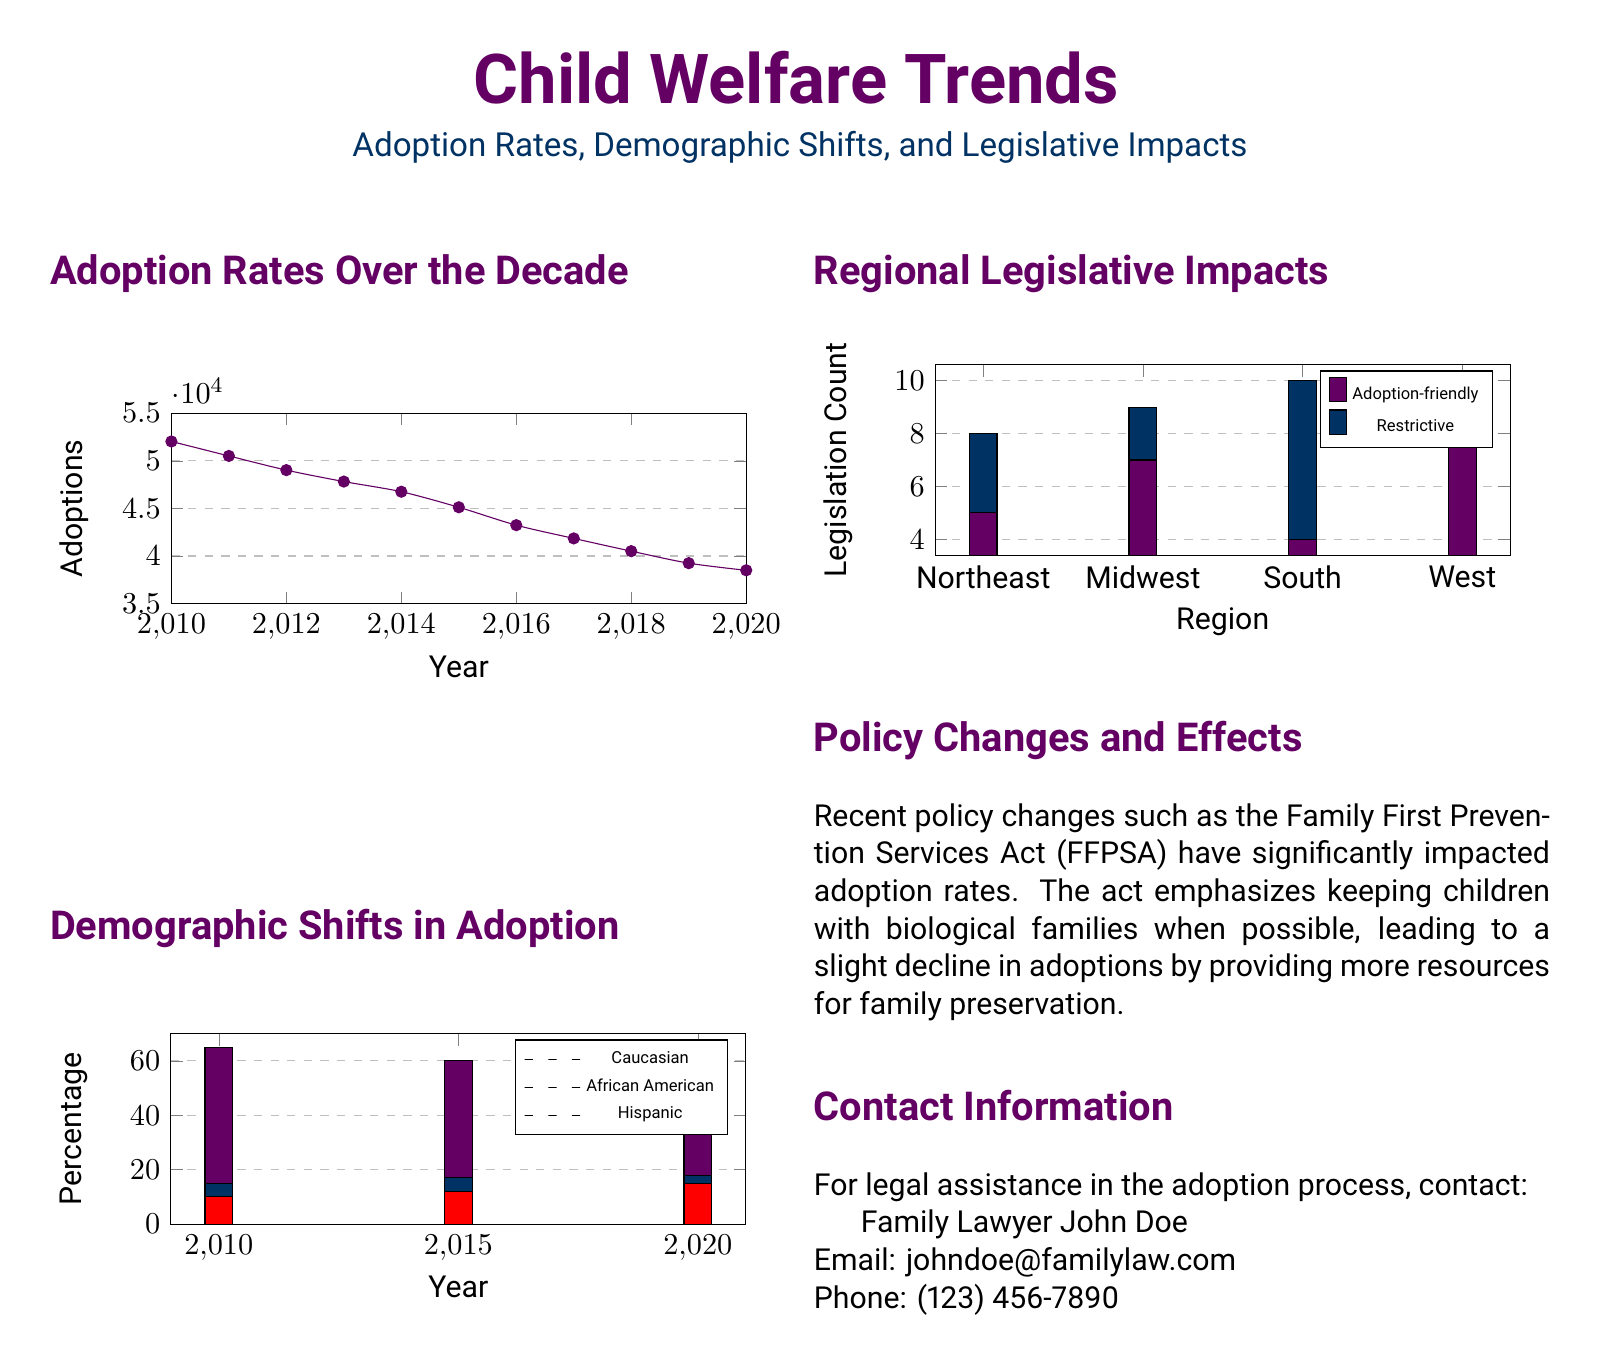What was the adoption rate in 2010? The adoption rate in 2010 is explicitly mentioned as 52034 adoptions.
Answer: 52034 What percentage of Caucasian adoptions was recorded in 2020? The percentage of Caucasian adoptions in 2020 is shown to be 55%.
Answer: 55% Which region had the highest count of adoption-friendly legislation? The region with the highest count of adoption-friendly legislation is West with a count of 8.
Answer: West How many African American adoptions were recorded in 2015? The number of African American adoptions in 2015 is represented as 17%.
Answer: 17% What legislative impact was most noted in the document? The document highlights the significant impact of the Family First Prevention Services Act (FFPSA) on adoption rates.
Answer: Family First Prevention Services Act What was the total number of adoptions in 2020? The total number of adoptions in 2020 is directly stated as 38500 adoptions.
Answer: 38500 What color represents Hispanic adoptions in the demographic shifts chart? The color red is used to represent Hispanic adoptions in the demographic shifts chart.
Answer: Red Which year saw the lowest adoption rate in the graph? The graph indicates that 2020 saw the lowest adoption rate with 38500 adoptions.
Answer: 2020 What is the contact name provided for legal assistance in adoption? The contact name for legal assistance is John Doe.
Answer: John Doe 